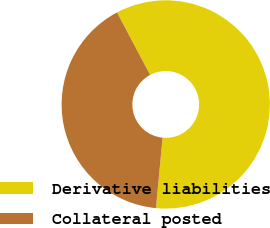<chart> <loc_0><loc_0><loc_500><loc_500><pie_chart><fcel>Derivative liabilities<fcel>Collateral posted<nl><fcel>59.25%<fcel>40.75%<nl></chart> 